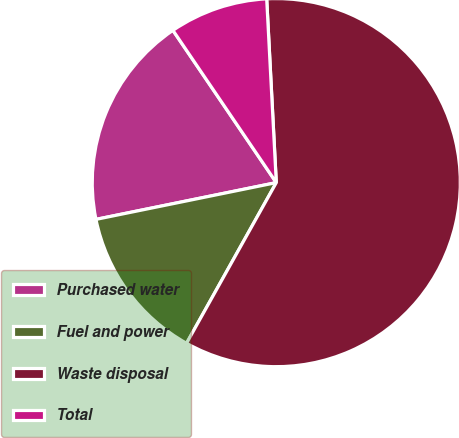<chart> <loc_0><loc_0><loc_500><loc_500><pie_chart><fcel>Purchased water<fcel>Fuel and power<fcel>Waste disposal<fcel>Total<nl><fcel>18.71%<fcel>13.69%<fcel>58.94%<fcel>8.66%<nl></chart> 